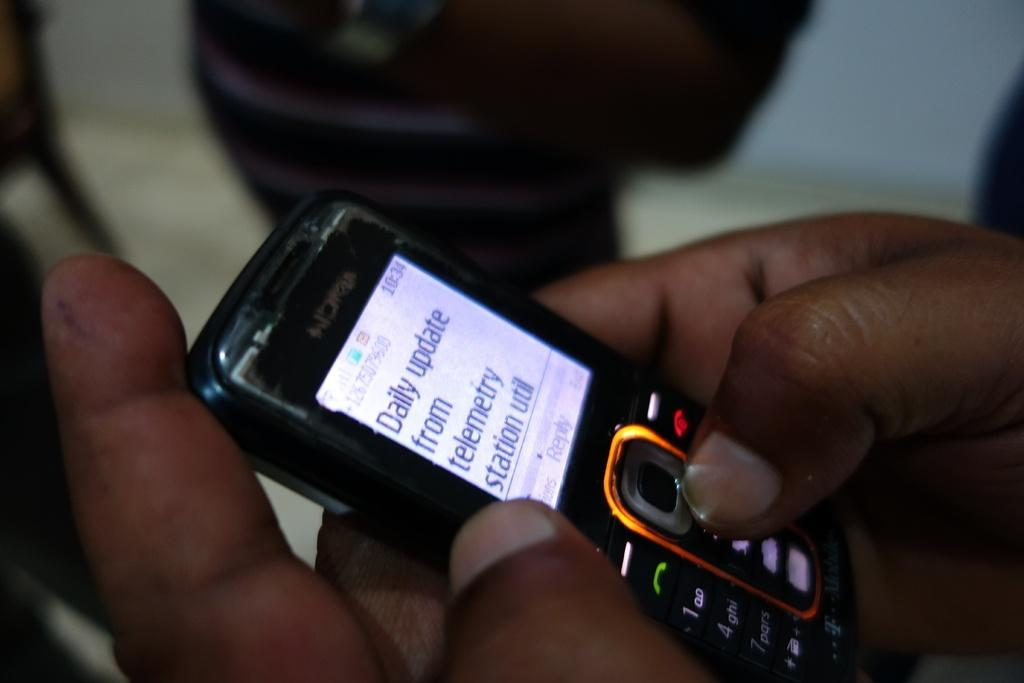<image>
Summarize the visual content of the image. A person holding a cellphone texting to a notification from a daily update from Telemetry Station Util. 